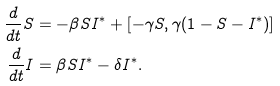Convert formula to latex. <formula><loc_0><loc_0><loc_500><loc_500>\frac { d } { d t } S & = - \beta S I ^ { * } + [ - \gamma S , \gamma ( 1 - S - I ^ { * } ) ] \\ \frac { d } { d t } I & = \beta S I ^ { * } - \delta I ^ { * } .</formula> 